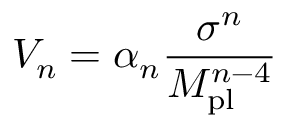<formula> <loc_0><loc_0><loc_500><loc_500>V _ { n } = \alpha _ { n } \frac { \sigma ^ { n } } { M _ { p l } ^ { n - 4 } }</formula> 